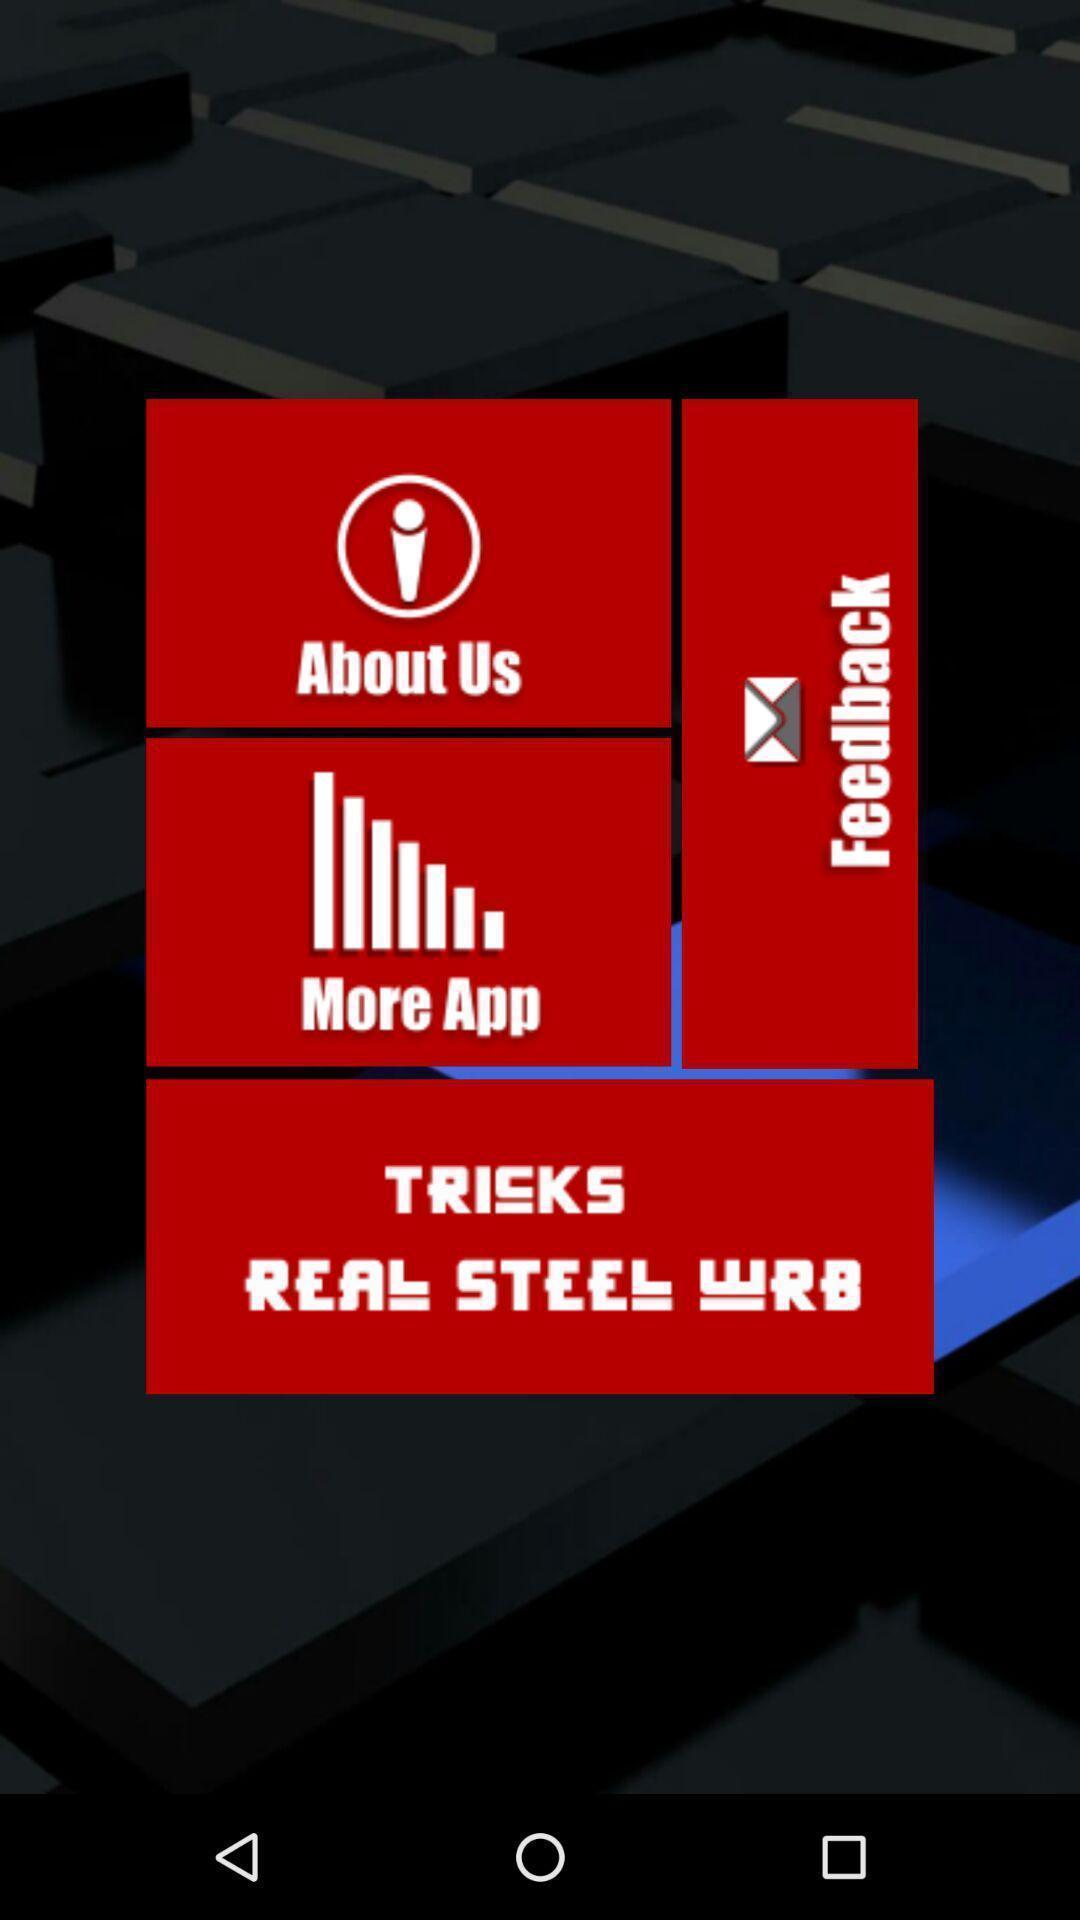Please provide a description for this image. Screen showing about us and feedback options. 